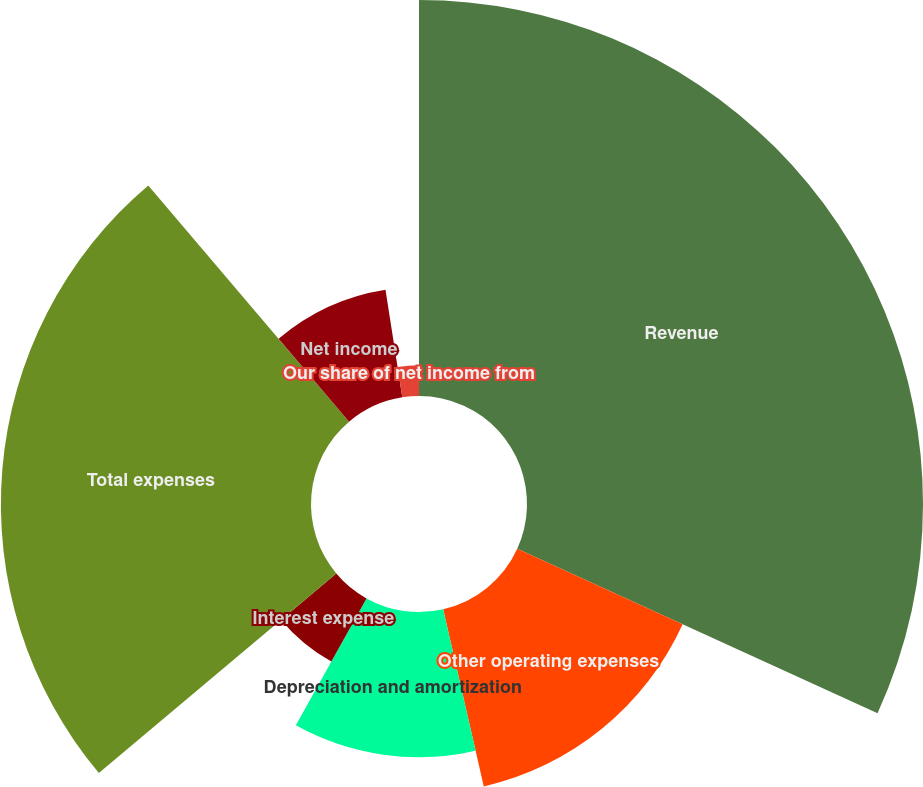Convert chart. <chart><loc_0><loc_0><loc_500><loc_500><pie_chart><fcel>Revenue<fcel>Other operating expenses<fcel>Depreciation and amortization<fcel>Interest expense<fcel>Total expenses<fcel>Net income<fcel>Our share of net income from<nl><fcel>31.81%<fcel>14.6%<fcel>11.67%<fcel>5.8%<fcel>24.91%<fcel>8.74%<fcel>2.47%<nl></chart> 